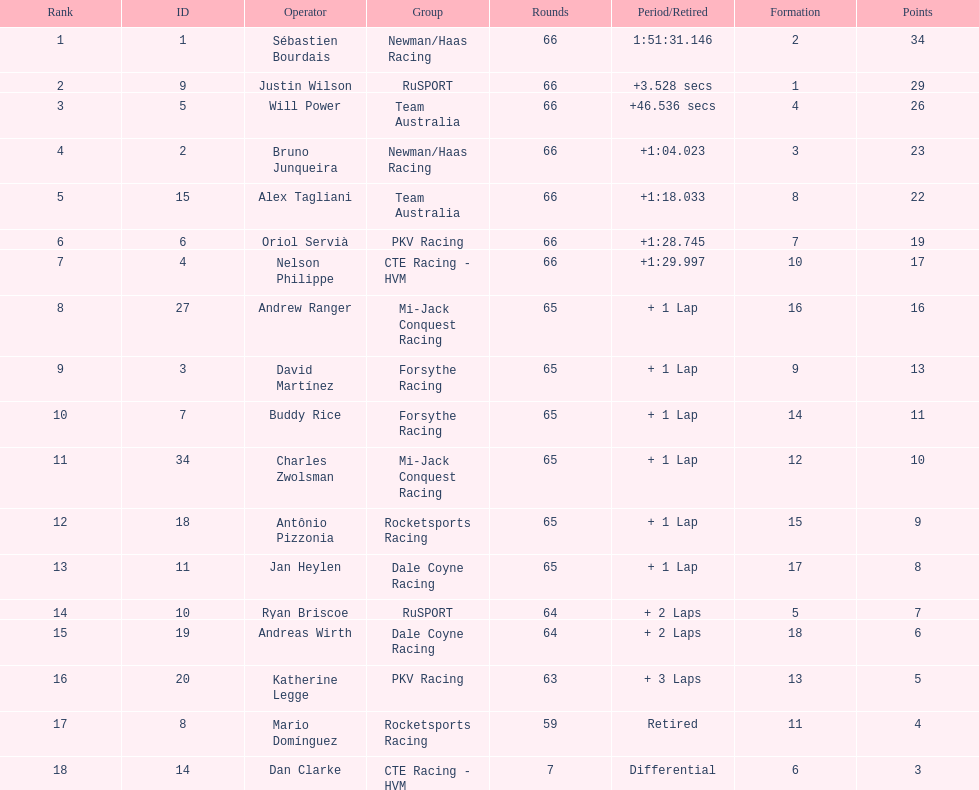At the 2006 gran premio telmex, who scored the highest number of points? Sébastien Bourdais. 